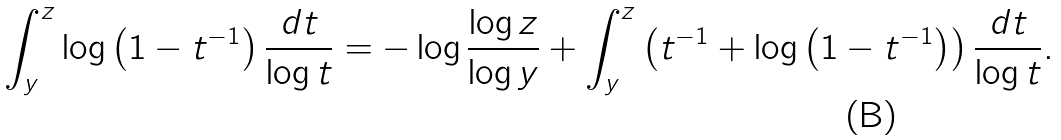Convert formula to latex. <formula><loc_0><loc_0><loc_500><loc_500>\int _ { y } ^ { z } \log \left ( 1 - t ^ { - 1 } \right ) \frac { d t } { \log t } = - \log \frac { \log z } { \log y } + \int _ { y } ^ { z } \left ( t ^ { - 1 } + \log \left ( 1 - t ^ { - 1 } \right ) \right ) \frac { d t } { \log t } .</formula> 